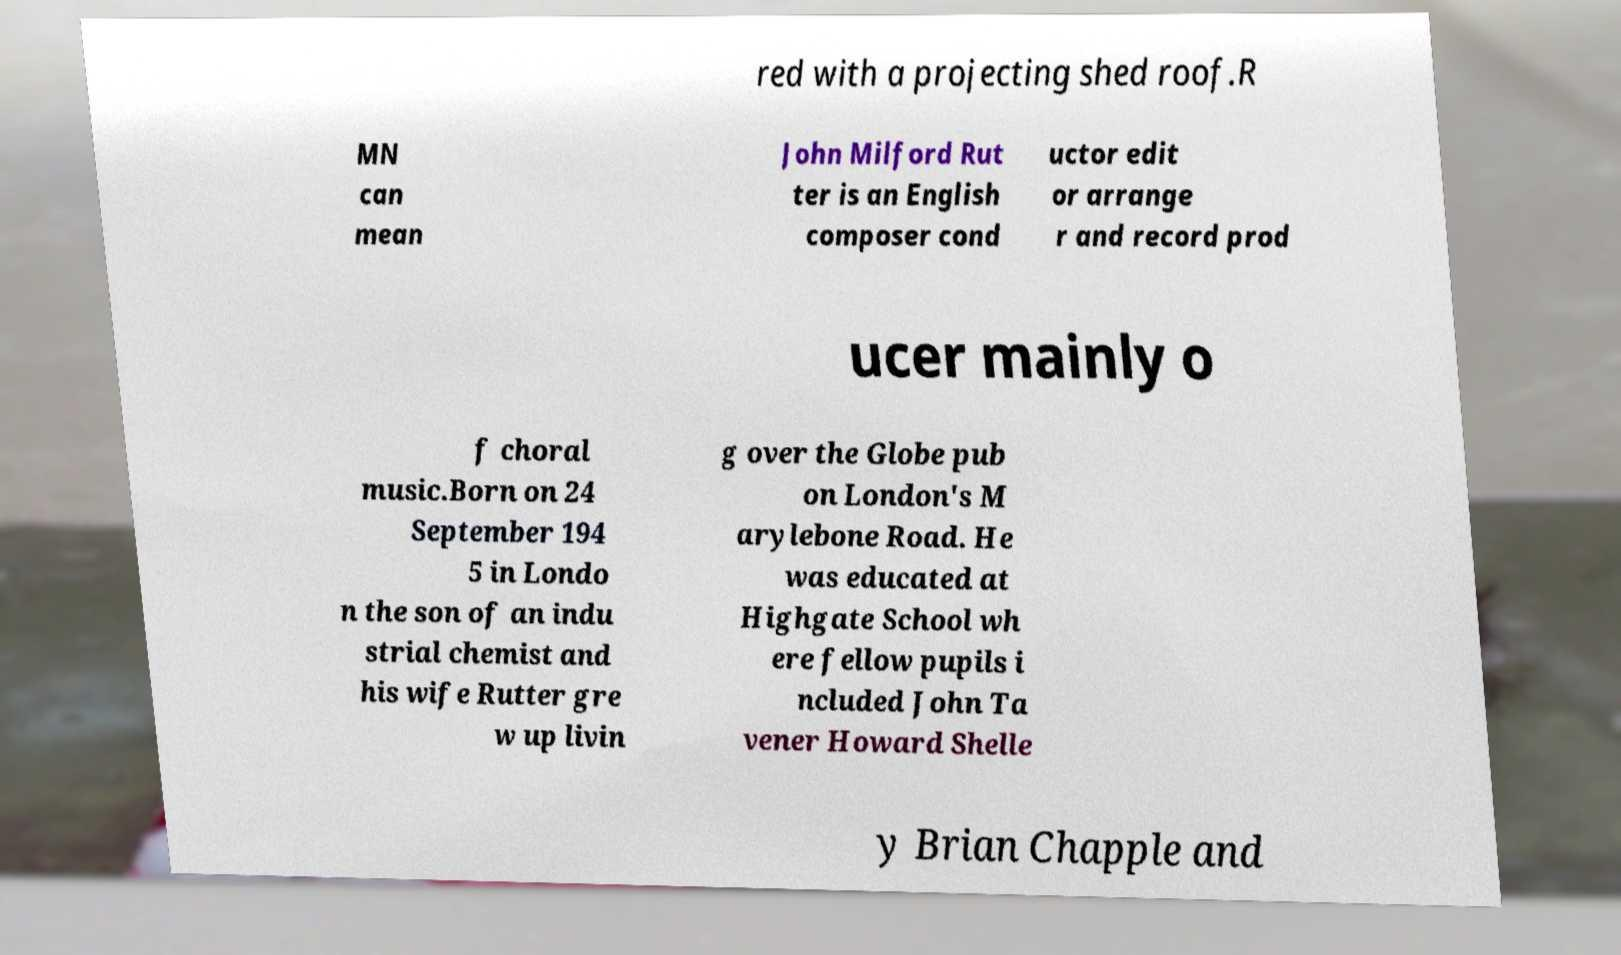Could you extract and type out the text from this image? red with a projecting shed roof.R MN can mean John Milford Rut ter is an English composer cond uctor edit or arrange r and record prod ucer mainly o f choral music.Born on 24 September 194 5 in Londo n the son of an indu strial chemist and his wife Rutter gre w up livin g over the Globe pub on London's M arylebone Road. He was educated at Highgate School wh ere fellow pupils i ncluded John Ta vener Howard Shelle y Brian Chapple and 